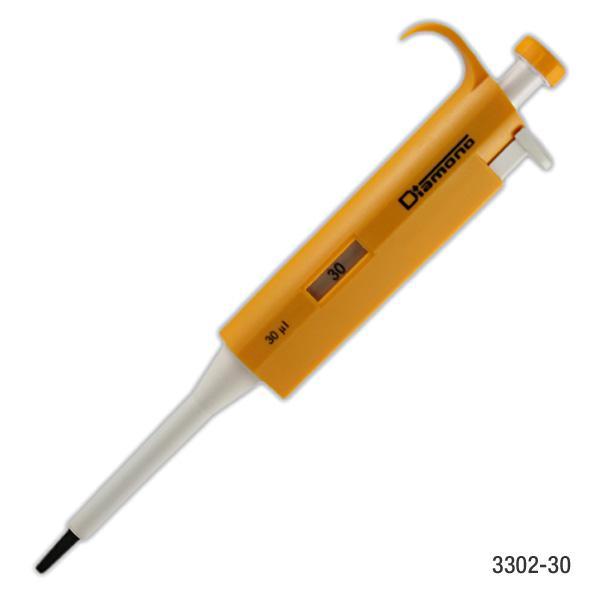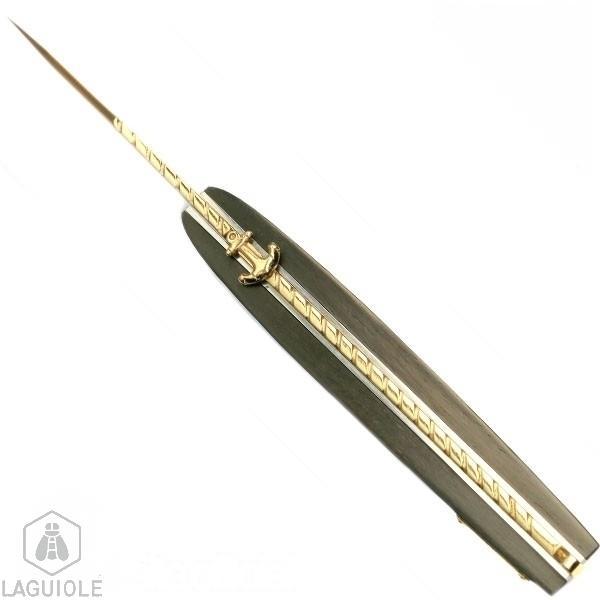The first image is the image on the left, the second image is the image on the right. For the images shown, is this caption "One of the syringes has a grey plunger." true? Answer yes or no. No. 